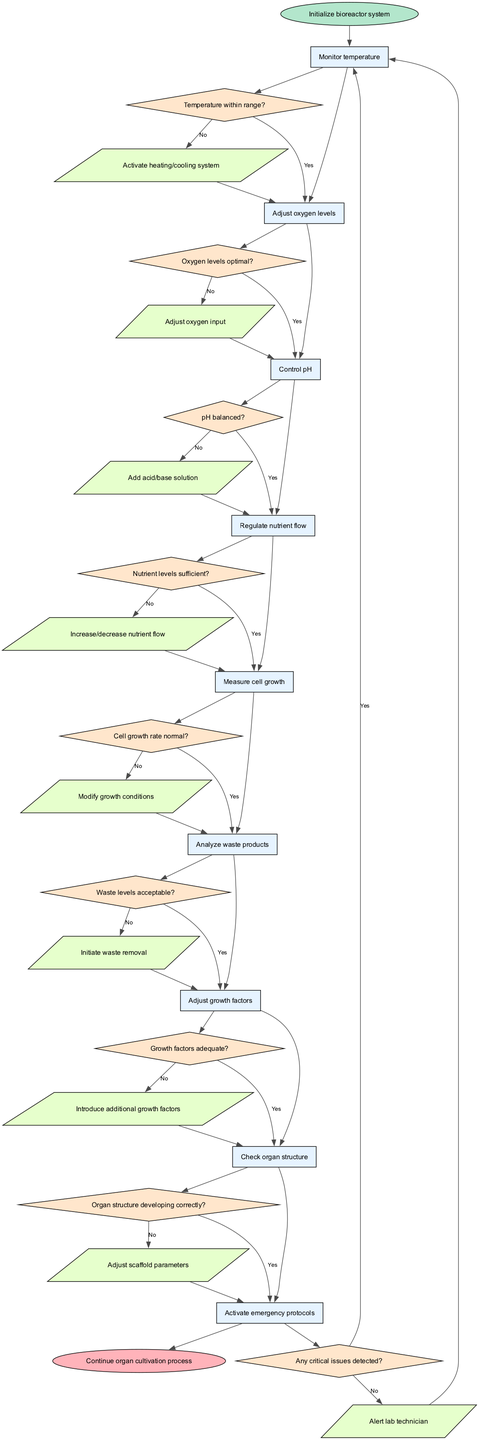What is the first action in the bioreactor control system? The diagram indicates that the first action is linked to the first node, "Monitor temperature," which is the first task in the sequence of operations. Therefore, the action associated with this node is "Activate heating/cooling system."
Answer: Activate heating/cooling system How many decisions are represented in the flowchart? By counting the number of decision nodes listed in the diagram, there are a total of nine decision points that guide the process based on the conditions of the bioreactor system.
Answer: 9 What is the final action taken before reaching the end of the process? The last action node before reaching the end is linked to the last decision, evaluating if "Organ structure developing correctly?" Therefore, the last action is "Adjust scaffold parameters."
Answer: Adjust scaffold parameters Which node connects directly to the end node? The node that connects directly to the end node is "Check organ structure," which serves as the last operational task before concluding the cultivation process.
Answer: Check organ structure If nutrient levels are sufficient, what is the next step? The flowchart shows that if the decision "Nutrient levels sufficient?" is answered as Yes, the flow proceeds directly to the next node, which is "Measure cell growth."
Answer: Measure cell growth What action is taken if oxygen levels are not optimal? The decision "Oxygen levels optimal?" leads to the action "Adjust oxygen input" if the answer is No, which is the action taken to rectify the condition of oxygen levels.
Answer: Adjust oxygen input What shape represents decision points in the flowchart? The decision points in the diagram are represented by diamond shapes, which are used to denote branching paths based on the answers to the posed questions.
Answer: Diamond How many nodes include monitoring or measuring tasks? There are three nodes that involve monitoring or measuring tasks: "Monitor temperature," "Measure cell growth," and "Analyze waste products." This reflects their roles in continuous assessment.
Answer: 3 What happens if a critical issue is detected during the process? If any critical issues are detected, the flow indicates to "Alert lab technician," thereby initiating a response to address the detected problems in the bioreactor.
Answer: Alert lab technician 